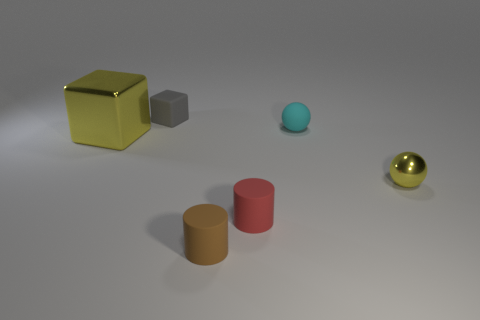Is there any other thing that is the same size as the yellow cube?
Provide a short and direct response. No. There is a matte thing that is both to the left of the tiny red cylinder and in front of the gray cube; how big is it?
Offer a very short reply. Small. How many cyan matte balls are there?
Your response must be concise. 1. There is a yellow thing that is the same size as the cyan sphere; what is its material?
Ensure brevity in your answer.  Metal. Is there a gray object of the same size as the brown matte cylinder?
Provide a succinct answer. Yes. There is a shiny object on the left side of the small red thing; does it have the same color as the metal object right of the gray rubber thing?
Provide a succinct answer. Yes. How many shiny things are small brown cylinders or purple balls?
Provide a short and direct response. 0. There is a yellow thing behind the yellow metallic object in front of the big yellow thing; how many small yellow things are behind it?
Your answer should be very brief. 0. What is the size of the other object that is made of the same material as the tiny yellow object?
Make the answer very short. Large. What number of things have the same color as the shiny cube?
Make the answer very short. 1. 